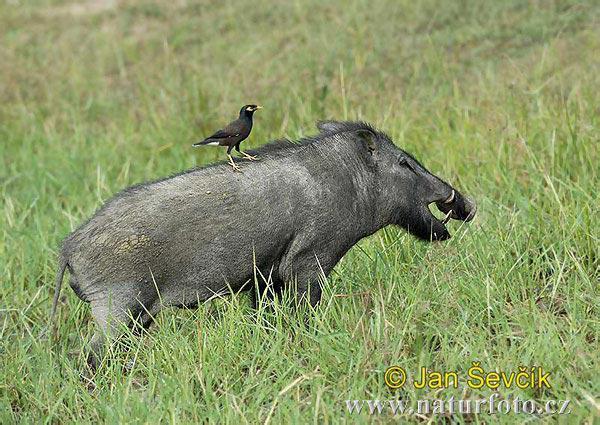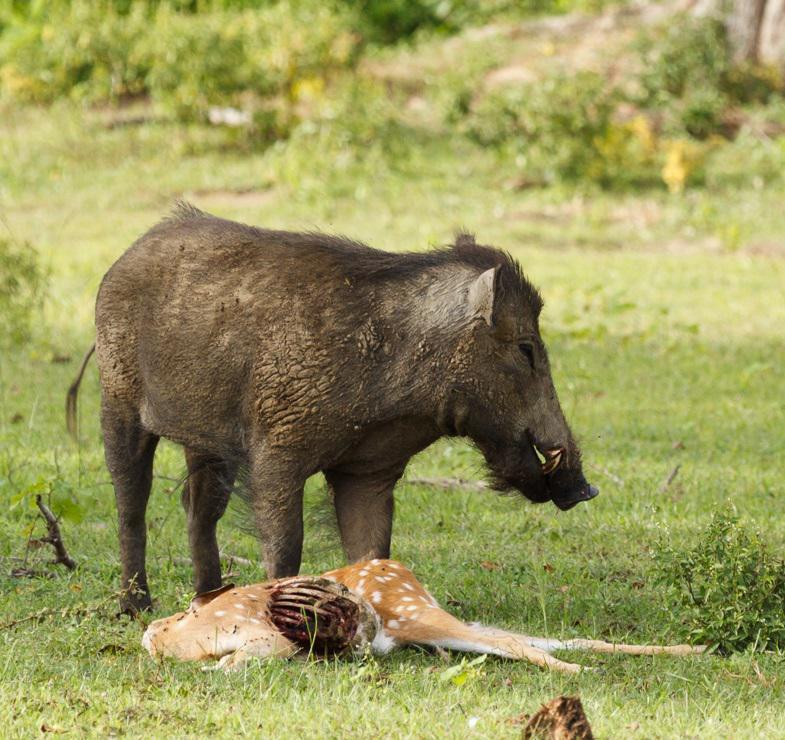The first image is the image on the left, the second image is the image on the right. Considering the images on both sides, is "An image shows a boar with its spotted deer-like prey animal." valid? Answer yes or no. Yes. The first image is the image on the left, the second image is the image on the right. Given the left and right images, does the statement "a hog is standing in water." hold true? Answer yes or no. No. 